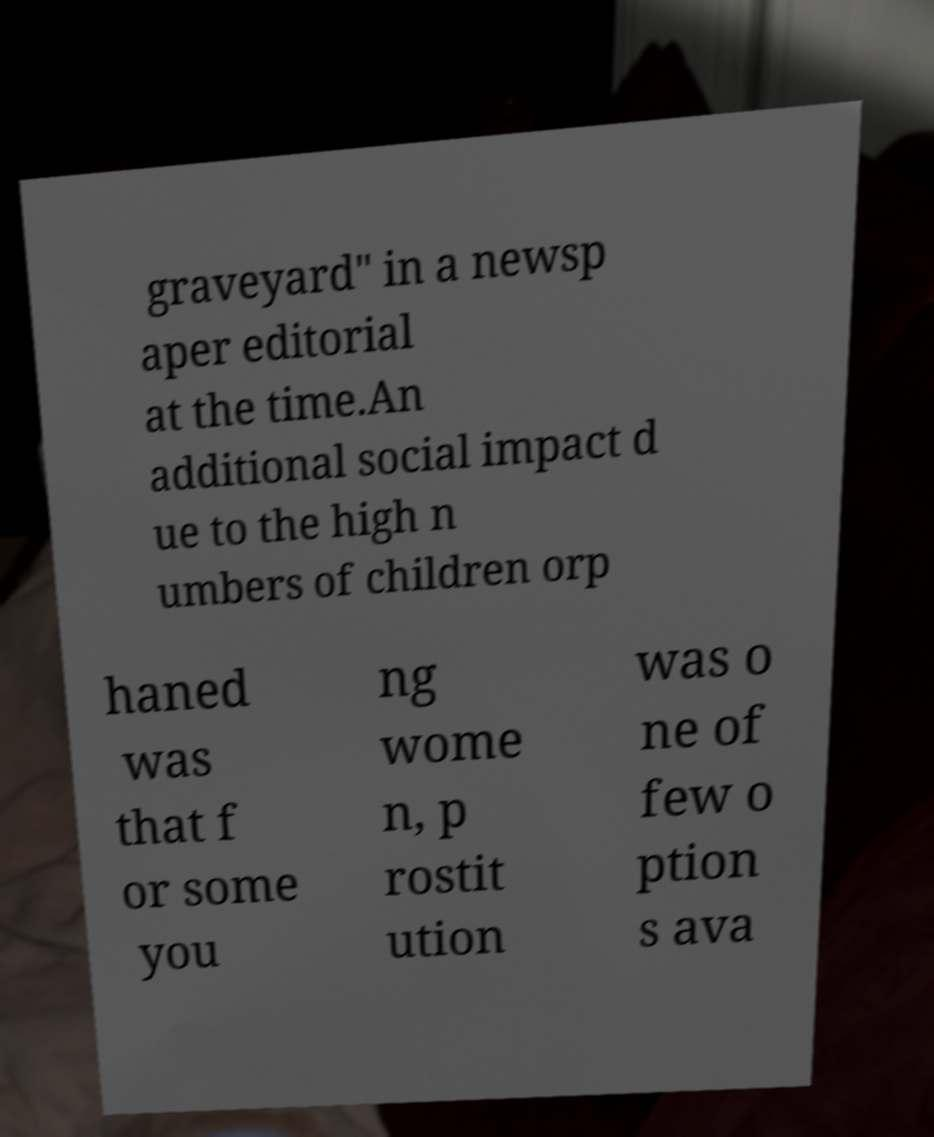Please read and relay the text visible in this image. What does it say? graveyard" in a newsp aper editorial at the time.An additional social impact d ue to the high n umbers of children orp haned was that f or some you ng wome n, p rostit ution was o ne of few o ption s ava 